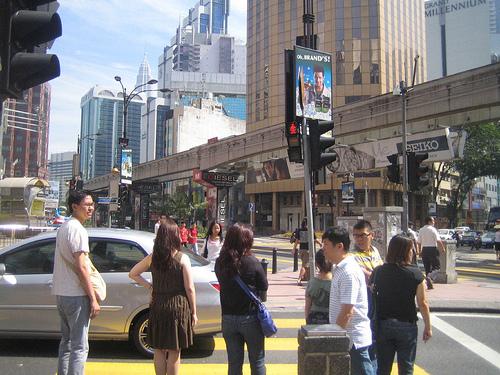Was this picture taken in a country setting?
Short answer required. No. What color are the stripes of the crosswalk?
Answer briefly. Yellow. Is this a rural area?
Concise answer only. No. 